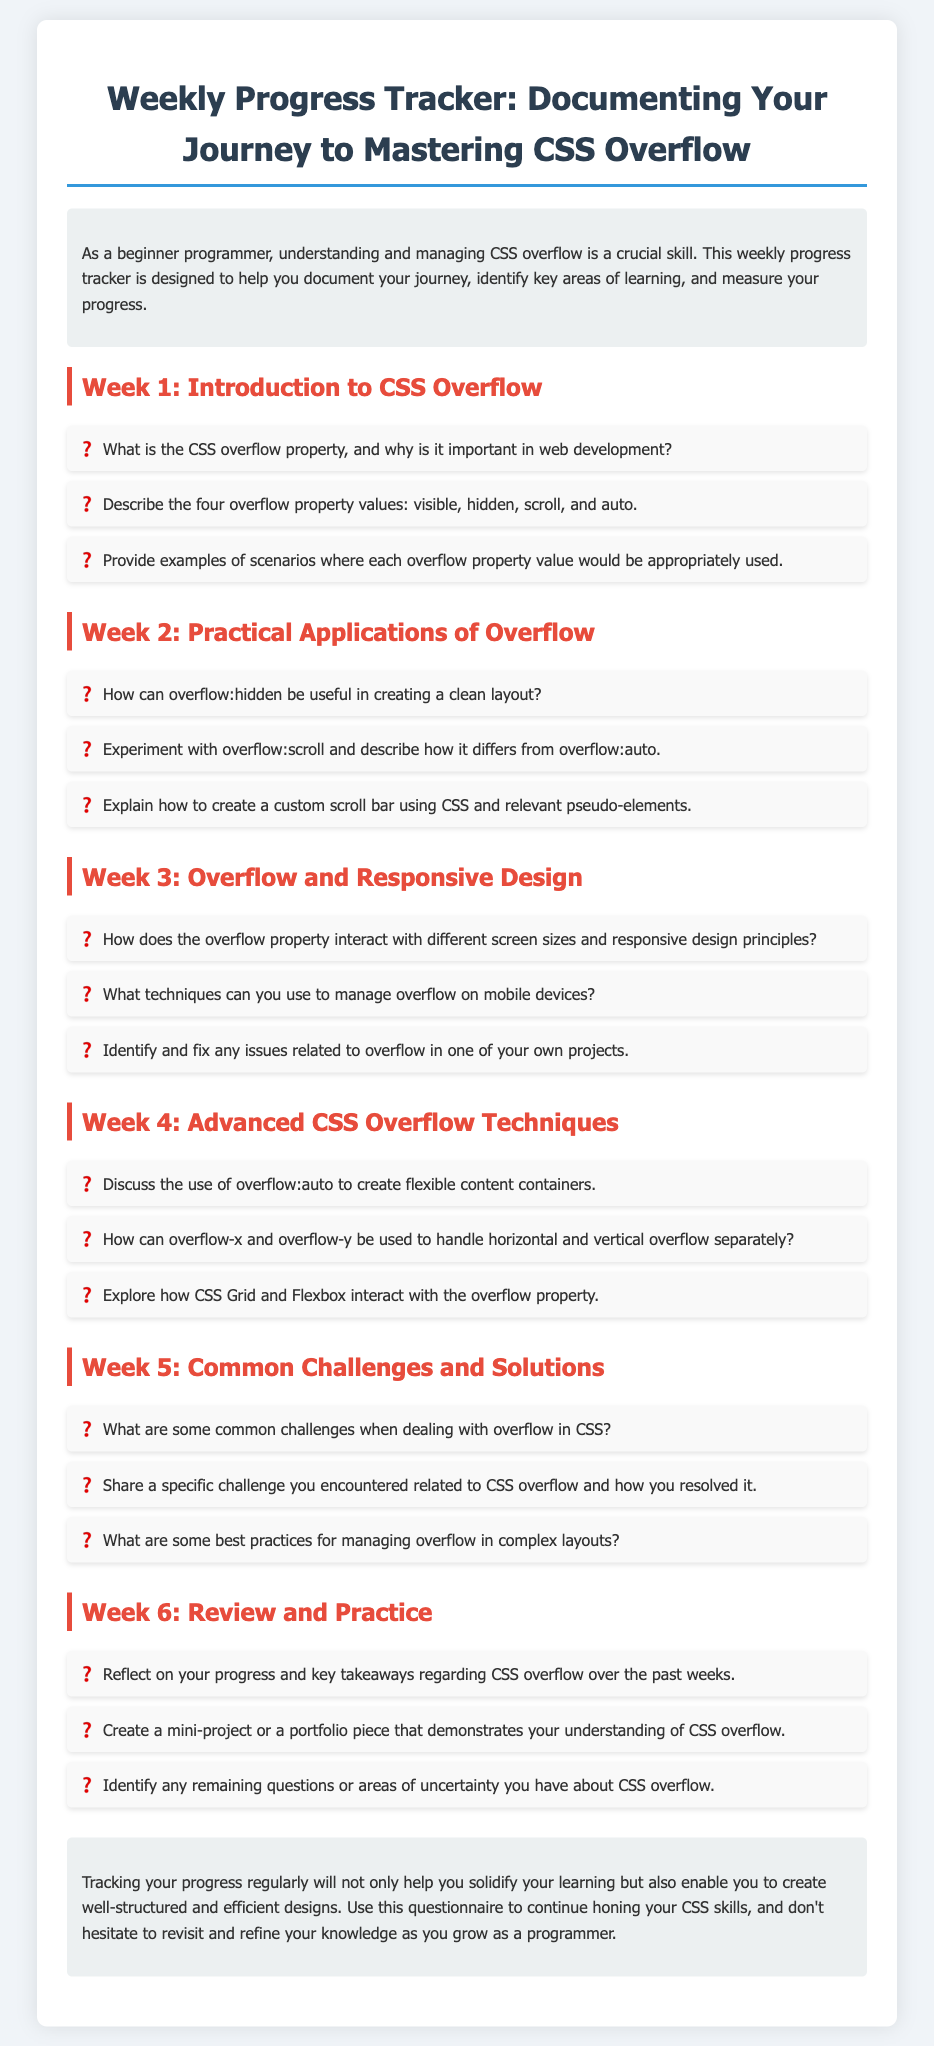What is the title of the document? The title is displayed at the top of the document, indicating the purpose of the content.
Answer: Weekly Progress Tracker: Documenting Your Journey to Mastering CSS Overflow What background color is used for the body? The background color is specified in the CSS for the overall body element of the document.
Answer: #f0f4f8 How many weeks are covered in the progress tracker? The document outlines progress over a specific number of weeks, which can be counted in the sections.
Answer: 6 What is the color of the headers in the sections? The color for the headers is mentioned in the CSS style rules for those elements in the document.
Answer: #e74c3c What technique is mentioned for overflow management on mobile devices? The document includes a question regarding techniques for handling overflow on mobile devices, indicating its relevance.
Answer: Techniques for managing overflow How can overflow-x and overflow-y be utilized? The document contains a specific question about the use of overflow-x and overflow-y.
Answer: Handle horizontal and vertical overflow separately What is a suggested activity for Week 6? The document includes actionable items for each week, detailing what to focus on in Week 6.
Answer: Create a mini-project or a portfolio piece What visual element indicates a question in the list? The document employs a specific stylistic choice to mark questions, making them visually distinct.
Answer: ❓ 